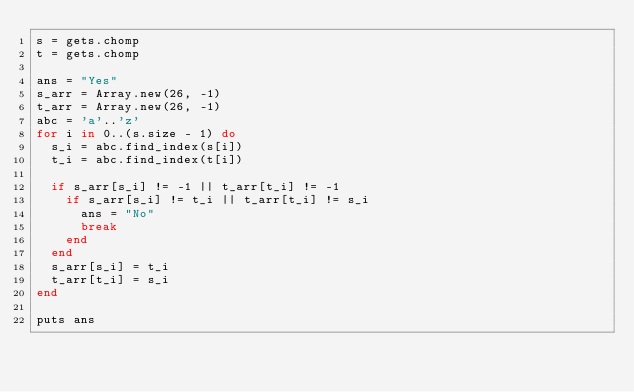Convert code to text. <code><loc_0><loc_0><loc_500><loc_500><_Ruby_>s = gets.chomp
t = gets.chomp

ans = "Yes"
s_arr = Array.new(26, -1)
t_arr = Array.new(26, -1)
abc = 'a'..'z'
for i in 0..(s.size - 1) do
  s_i = abc.find_index(s[i])
  t_i = abc.find_index(t[i])

  if s_arr[s_i] != -1 || t_arr[t_i] != -1
    if s_arr[s_i] != t_i || t_arr[t_i] != s_i
      ans = "No"
      break
    end
  end
  s_arr[s_i] = t_i
  t_arr[t_i] = s_i
end

puts ans</code> 